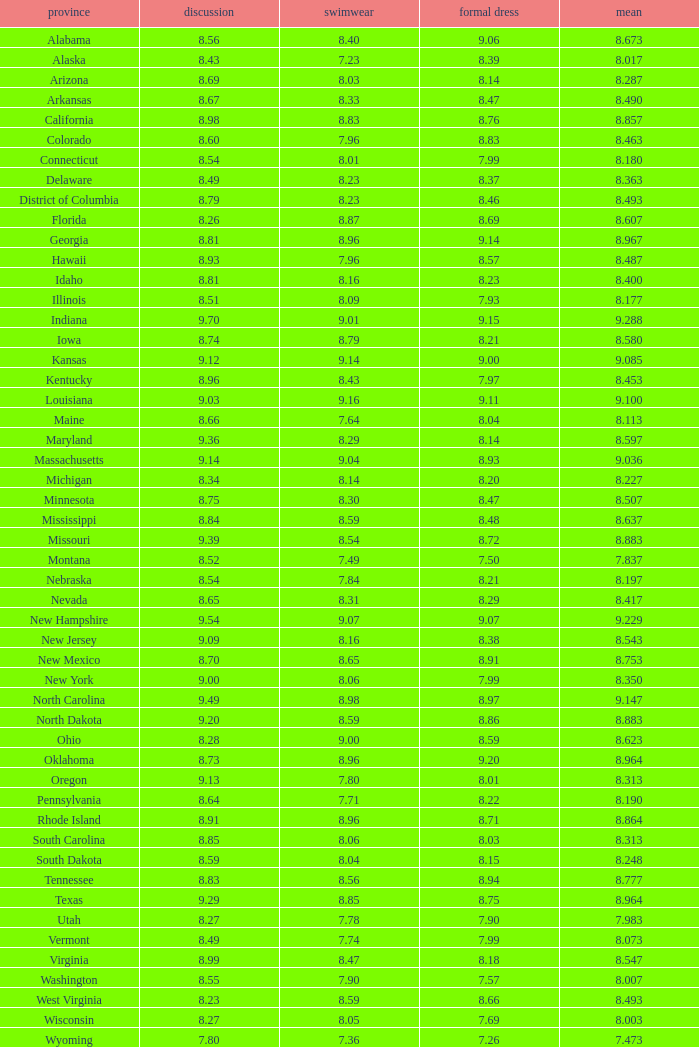Name the total number of swimsuits for evening gowns less than 8.21 and average of 8.453 with interview less than 9.09 1.0. Write the full table. {'header': ['province', 'discussion', 'swimwear', 'formal dress', 'mean'], 'rows': [['Alabama', '8.56', '8.40', '9.06', '8.673'], ['Alaska', '8.43', '7.23', '8.39', '8.017'], ['Arizona', '8.69', '8.03', '8.14', '8.287'], ['Arkansas', '8.67', '8.33', '8.47', '8.490'], ['California', '8.98', '8.83', '8.76', '8.857'], ['Colorado', '8.60', '7.96', '8.83', '8.463'], ['Connecticut', '8.54', '8.01', '7.99', '8.180'], ['Delaware', '8.49', '8.23', '8.37', '8.363'], ['District of Columbia', '8.79', '8.23', '8.46', '8.493'], ['Florida', '8.26', '8.87', '8.69', '8.607'], ['Georgia', '8.81', '8.96', '9.14', '8.967'], ['Hawaii', '8.93', '7.96', '8.57', '8.487'], ['Idaho', '8.81', '8.16', '8.23', '8.400'], ['Illinois', '8.51', '8.09', '7.93', '8.177'], ['Indiana', '9.70', '9.01', '9.15', '9.288'], ['Iowa', '8.74', '8.79', '8.21', '8.580'], ['Kansas', '9.12', '9.14', '9.00', '9.085'], ['Kentucky', '8.96', '8.43', '7.97', '8.453'], ['Louisiana', '9.03', '9.16', '9.11', '9.100'], ['Maine', '8.66', '7.64', '8.04', '8.113'], ['Maryland', '9.36', '8.29', '8.14', '8.597'], ['Massachusetts', '9.14', '9.04', '8.93', '9.036'], ['Michigan', '8.34', '8.14', '8.20', '8.227'], ['Minnesota', '8.75', '8.30', '8.47', '8.507'], ['Mississippi', '8.84', '8.59', '8.48', '8.637'], ['Missouri', '9.39', '8.54', '8.72', '8.883'], ['Montana', '8.52', '7.49', '7.50', '7.837'], ['Nebraska', '8.54', '7.84', '8.21', '8.197'], ['Nevada', '8.65', '8.31', '8.29', '8.417'], ['New Hampshire', '9.54', '9.07', '9.07', '9.229'], ['New Jersey', '9.09', '8.16', '8.38', '8.543'], ['New Mexico', '8.70', '8.65', '8.91', '8.753'], ['New York', '9.00', '8.06', '7.99', '8.350'], ['North Carolina', '9.49', '8.98', '8.97', '9.147'], ['North Dakota', '9.20', '8.59', '8.86', '8.883'], ['Ohio', '8.28', '9.00', '8.59', '8.623'], ['Oklahoma', '8.73', '8.96', '9.20', '8.964'], ['Oregon', '9.13', '7.80', '8.01', '8.313'], ['Pennsylvania', '8.64', '7.71', '8.22', '8.190'], ['Rhode Island', '8.91', '8.96', '8.71', '8.864'], ['South Carolina', '8.85', '8.06', '8.03', '8.313'], ['South Dakota', '8.59', '8.04', '8.15', '8.248'], ['Tennessee', '8.83', '8.56', '8.94', '8.777'], ['Texas', '9.29', '8.85', '8.75', '8.964'], ['Utah', '8.27', '7.78', '7.90', '7.983'], ['Vermont', '8.49', '7.74', '7.99', '8.073'], ['Virginia', '8.99', '8.47', '8.18', '8.547'], ['Washington', '8.55', '7.90', '7.57', '8.007'], ['West Virginia', '8.23', '8.59', '8.66', '8.493'], ['Wisconsin', '8.27', '8.05', '7.69', '8.003'], ['Wyoming', '7.80', '7.36', '7.26', '7.473']]} 